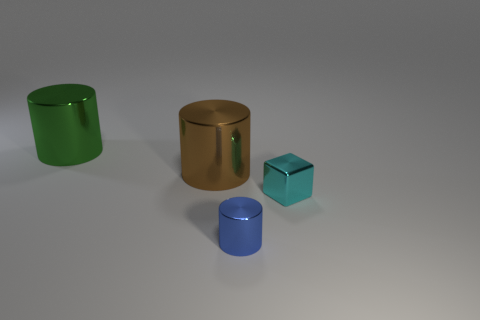Add 1 cyan spheres. How many objects exist? 5 Subtract all blocks. How many objects are left? 3 Subtract 0 purple spheres. How many objects are left? 4 Subtract all small red matte balls. Subtract all cyan shiny objects. How many objects are left? 3 Add 4 blue objects. How many blue objects are left? 5 Add 2 small cylinders. How many small cylinders exist? 3 